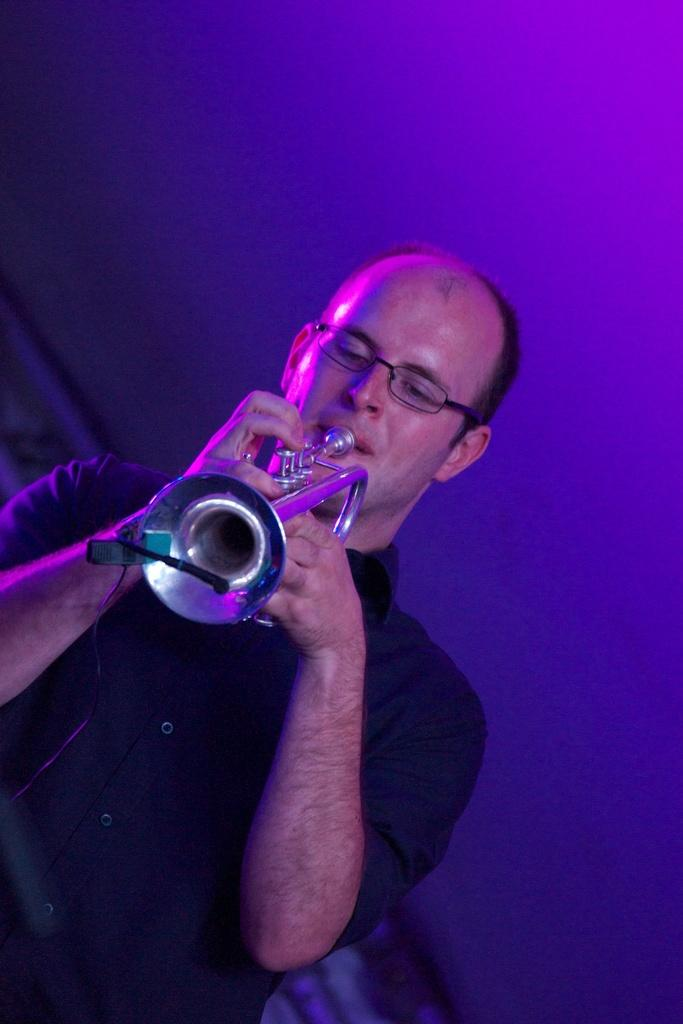What is the main subject of the image? There is a person in the image. What is the person holding in the image? The person is holding a trumpet. What other object can be seen in the image? There is a microphone with a cable in the image. What type of sky can be seen in the image? There is no sky visible in the image; it is focused on the person, the trumpet, and the microphone. 